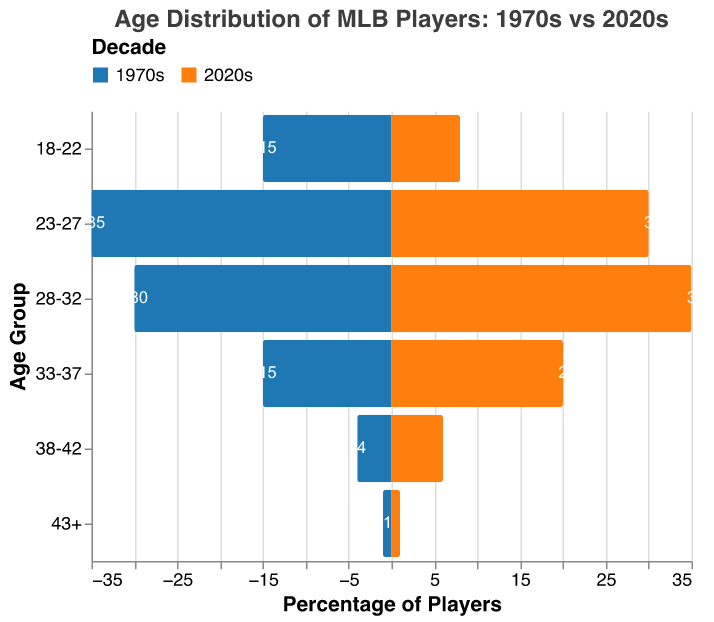What is the title of the figure? The title is located at the top of the figure and it provides a brief summary of what the figure represents: "Age Distribution of MLB Players: 1970s vs 2020s".
Answer: Age Distribution of MLB Players: 1970s vs 2020s Which age group had the most players in the 1970s? Look at the blue bars representing the 1970s; the tallest bar indicates the age group with the most players. For the 1970s, the tallest bar is for the "23-27" age group.
Answer: 23-27 How many players in the 33-37 age group are there in the 2020s compared to the 1970s? Compare the heights of the orange bar (2020s) and the blue bar (1970s) for the "33-37" age group. The number of players was 20 in the 2020s and 15 in the 1970s.
Answer: 20 in the 2020s, 15 in the 1970s What is the difference in the percentage of players in the "18-22" age group between the 1970s and 2020s? Subtract the value of the orange bar (2020s) from the value of the blue bar (1970s) for the "18-22" age group. The difference is 15 - 8 = 7.
Answer: 7 Which age group saw an increase in player percentage from the 1970s to the 2020s? Compare each age group between the two decades by looking at the bars. The "28-32" and "33-37" age groups both saw increases (30 to 35 and 15 to 20, respectively).
Answer: 28-32 and 33-37 How does the number of players in the 28-32 age group compare between the two decades? Compare the values of the 28-32 age group for both decades. The 1970s have 30, whereas the 2020s have 35.
Answer: 35 in the 2020s, 30 in the 1970s Which age group has the smallest number of players in both decades? Identify the age group with the shortest bars for both decades. The "43+" age group has the smallest number of players in both the 1970s and 2020s, with only 1 player each.
Answer: 43+ What is the total number of players in the "38-42" and "43+" age groups in the 2020s? Add the number of players in the "38-42" and "43+" age groups for the 2020s: 6 + 1 = 7.
Answer: 7 Which decade had more players in the "23-27" age group? Compare the height/values of the bars for the "23-27" age group. The 1970s have more players (35 vs. 30).
Answer: 1970s What is the median age group for players in the 2020s? Since the data is already sorted by age groups, identify the middle value by arranging the player counts in ascending order and finding the middle value or average of the two middle values. The age group 28-32 is in the middle.
Answer: 28-32 